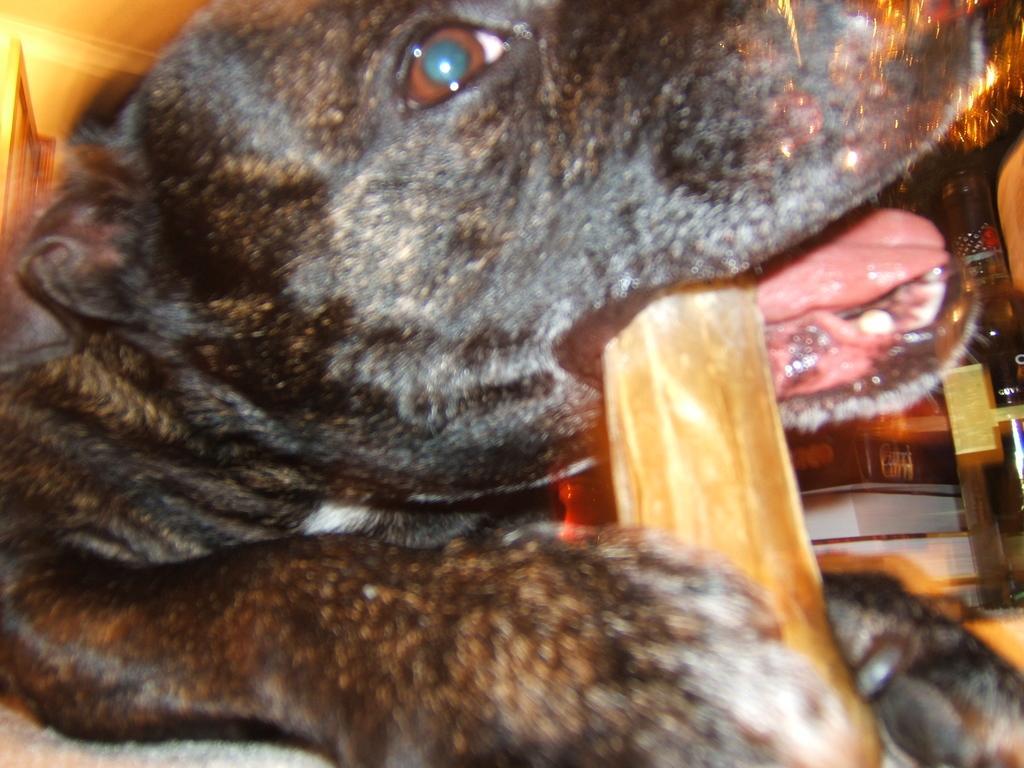Describe this image in one or two sentences. In this picture I can see a dog holding an object with mouth, right side of the image we can see chair, books. 